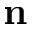<formula> <loc_0><loc_0><loc_500><loc_500>{ n }</formula> 